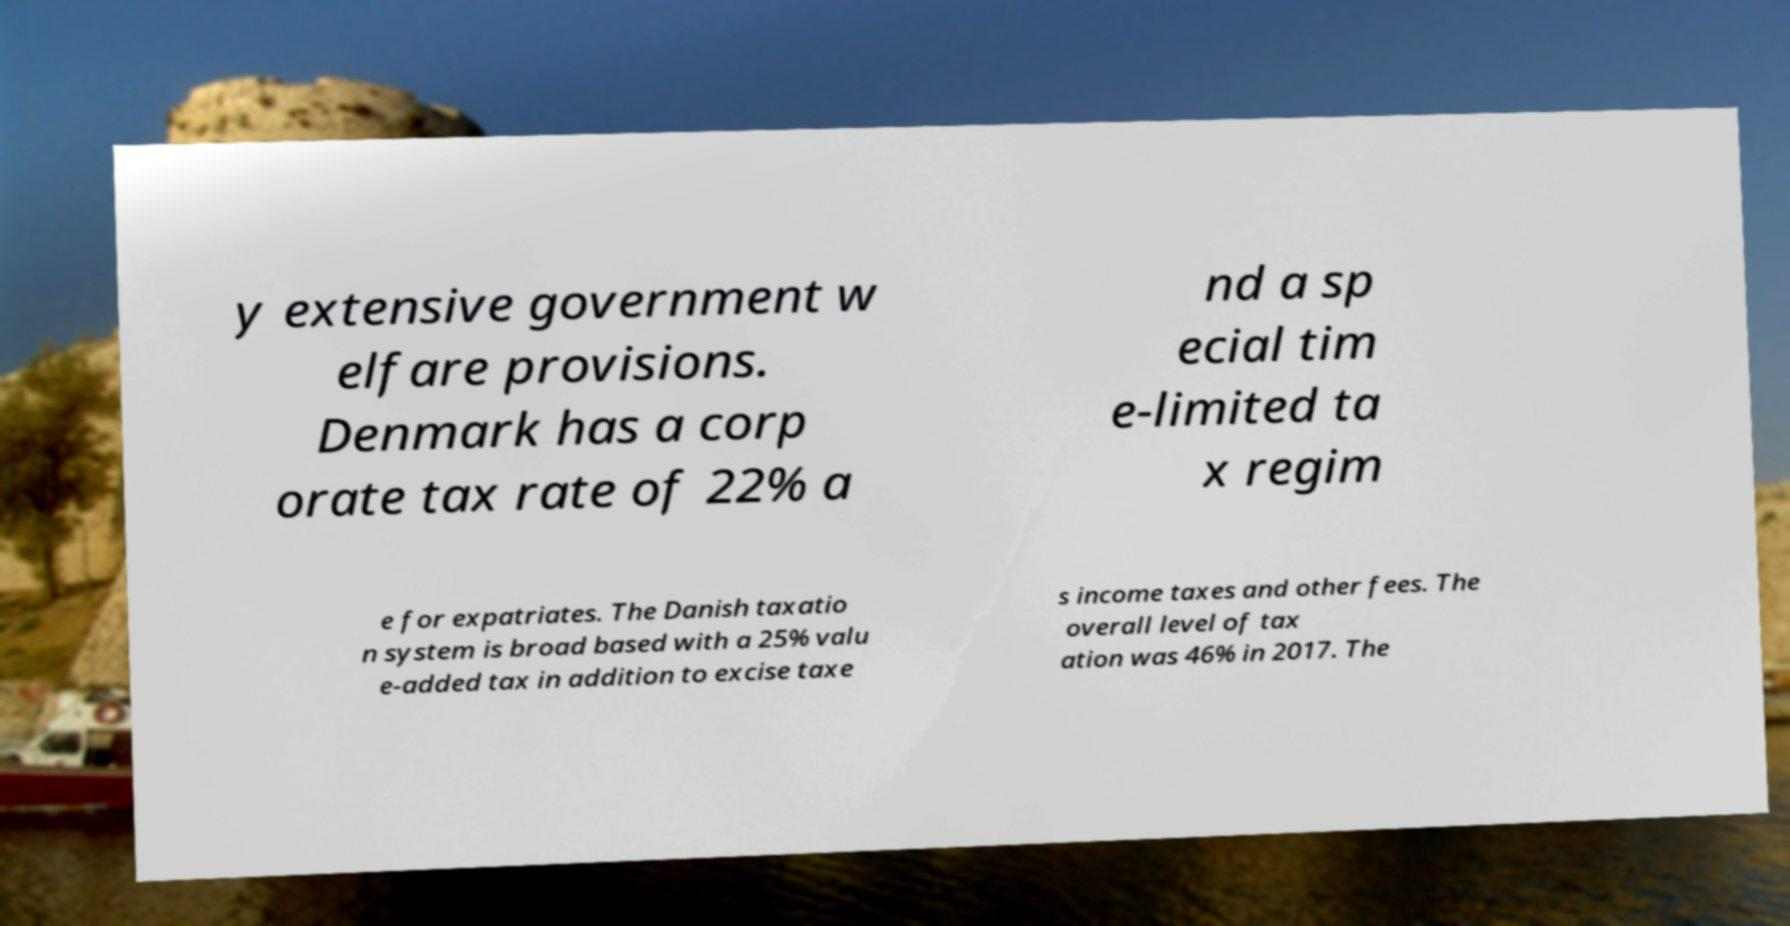For documentation purposes, I need the text within this image transcribed. Could you provide that? y extensive government w elfare provisions. Denmark has a corp orate tax rate of 22% a nd a sp ecial tim e-limited ta x regim e for expatriates. The Danish taxatio n system is broad based with a 25% valu e-added tax in addition to excise taxe s income taxes and other fees. The overall level of tax ation was 46% in 2017. The 